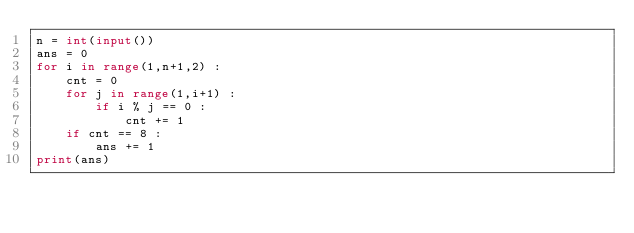Convert code to text. <code><loc_0><loc_0><loc_500><loc_500><_Python_>n = int(input())
ans = 0
for i in range(1,n+1,2) :
	cnt = 0
	for j in range(1,i+1) :
		if i % j == 0 :
        	cnt += 1
	if cnt == 8 :
		ans += 1
print(ans)     
</code> 